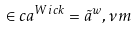<formula> <loc_0><loc_0><loc_500><loc_500>\in c a ^ { W i c k } = \tilde { a } ^ { w } , \nu m</formula> 